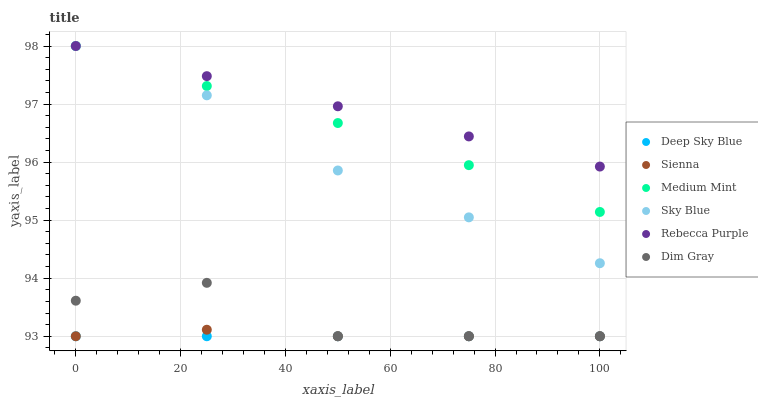Does Deep Sky Blue have the minimum area under the curve?
Answer yes or no. Yes. Does Rebecca Purple have the maximum area under the curve?
Answer yes or no. Yes. Does Dim Gray have the minimum area under the curve?
Answer yes or no. No. Does Dim Gray have the maximum area under the curve?
Answer yes or no. No. Is Deep Sky Blue the smoothest?
Answer yes or no. Yes. Is Dim Gray the roughest?
Answer yes or no. Yes. Is Sienna the smoothest?
Answer yes or no. No. Is Sienna the roughest?
Answer yes or no. No. Does Dim Gray have the lowest value?
Answer yes or no. Yes. Does Rebecca Purple have the lowest value?
Answer yes or no. No. Does Sky Blue have the highest value?
Answer yes or no. Yes. Does Dim Gray have the highest value?
Answer yes or no. No. Is Sienna less than Medium Mint?
Answer yes or no. Yes. Is Sky Blue greater than Dim Gray?
Answer yes or no. Yes. Does Sky Blue intersect Medium Mint?
Answer yes or no. Yes. Is Sky Blue less than Medium Mint?
Answer yes or no. No. Is Sky Blue greater than Medium Mint?
Answer yes or no. No. Does Sienna intersect Medium Mint?
Answer yes or no. No. 